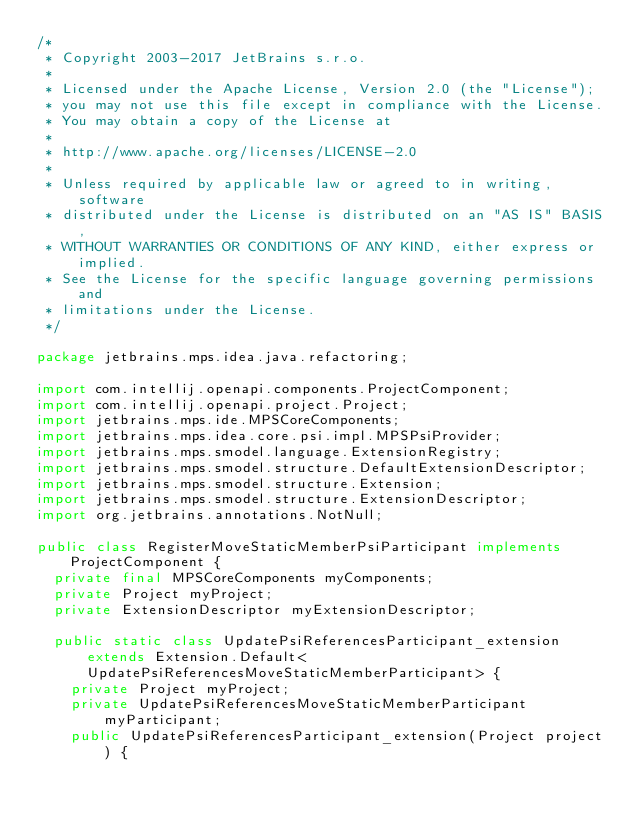Convert code to text. <code><loc_0><loc_0><loc_500><loc_500><_Java_>/*
 * Copyright 2003-2017 JetBrains s.r.o.
 *
 * Licensed under the Apache License, Version 2.0 (the "License");
 * you may not use this file except in compliance with the License.
 * You may obtain a copy of the License at
 *
 * http://www.apache.org/licenses/LICENSE-2.0
 *
 * Unless required by applicable law or agreed to in writing, software
 * distributed under the License is distributed on an "AS IS" BASIS,
 * WITHOUT WARRANTIES OR CONDITIONS OF ANY KIND, either express or implied.
 * See the License for the specific language governing permissions and
 * limitations under the License.
 */

package jetbrains.mps.idea.java.refactoring;

import com.intellij.openapi.components.ProjectComponent;
import com.intellij.openapi.project.Project;
import jetbrains.mps.ide.MPSCoreComponents;
import jetbrains.mps.idea.core.psi.impl.MPSPsiProvider;
import jetbrains.mps.smodel.language.ExtensionRegistry;
import jetbrains.mps.smodel.structure.DefaultExtensionDescriptor;
import jetbrains.mps.smodel.structure.Extension;
import jetbrains.mps.smodel.structure.ExtensionDescriptor;
import org.jetbrains.annotations.NotNull;

public class RegisterMoveStaticMemberPsiParticipant implements ProjectComponent {
  private final MPSCoreComponents myComponents;
  private Project myProject;
  private ExtensionDescriptor myExtensionDescriptor;

  public static class UpdatePsiReferencesParticipant_extension extends Extension.Default<UpdatePsiReferencesMoveStaticMemberParticipant> {
    private Project myProject;
    private UpdatePsiReferencesMoveStaticMemberParticipant myParticipant;
    public UpdatePsiReferencesParticipant_extension(Project project) {</code> 